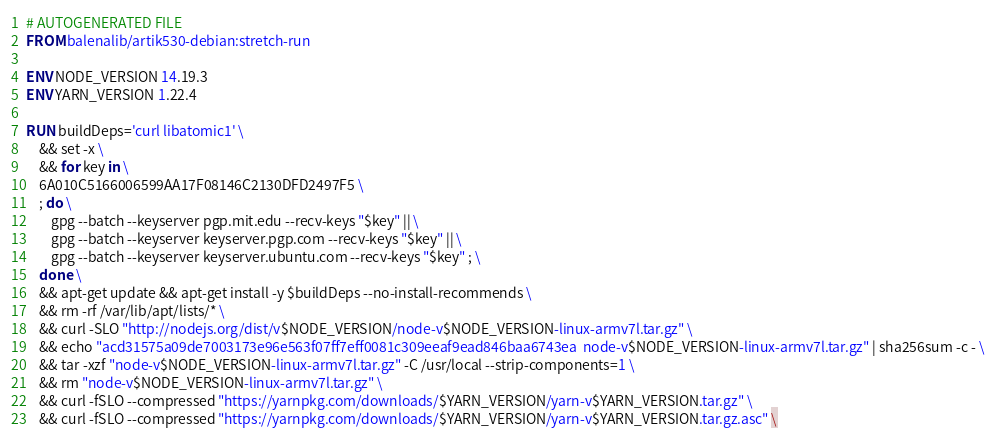Convert code to text. <code><loc_0><loc_0><loc_500><loc_500><_Dockerfile_># AUTOGENERATED FILE
FROM balenalib/artik530-debian:stretch-run

ENV NODE_VERSION 14.19.3
ENV YARN_VERSION 1.22.4

RUN buildDeps='curl libatomic1' \
	&& set -x \
	&& for key in \
	6A010C5166006599AA17F08146C2130DFD2497F5 \
	; do \
		gpg --batch --keyserver pgp.mit.edu --recv-keys "$key" || \
		gpg --batch --keyserver keyserver.pgp.com --recv-keys "$key" || \
		gpg --batch --keyserver keyserver.ubuntu.com --recv-keys "$key" ; \
	done \
	&& apt-get update && apt-get install -y $buildDeps --no-install-recommends \
	&& rm -rf /var/lib/apt/lists/* \
	&& curl -SLO "http://nodejs.org/dist/v$NODE_VERSION/node-v$NODE_VERSION-linux-armv7l.tar.gz" \
	&& echo "acd31575a09de7003173e96e563f07ff7eff0081c309eeaf9ead846baa6743ea  node-v$NODE_VERSION-linux-armv7l.tar.gz" | sha256sum -c - \
	&& tar -xzf "node-v$NODE_VERSION-linux-armv7l.tar.gz" -C /usr/local --strip-components=1 \
	&& rm "node-v$NODE_VERSION-linux-armv7l.tar.gz" \
	&& curl -fSLO --compressed "https://yarnpkg.com/downloads/$YARN_VERSION/yarn-v$YARN_VERSION.tar.gz" \
	&& curl -fSLO --compressed "https://yarnpkg.com/downloads/$YARN_VERSION/yarn-v$YARN_VERSION.tar.gz.asc" \</code> 